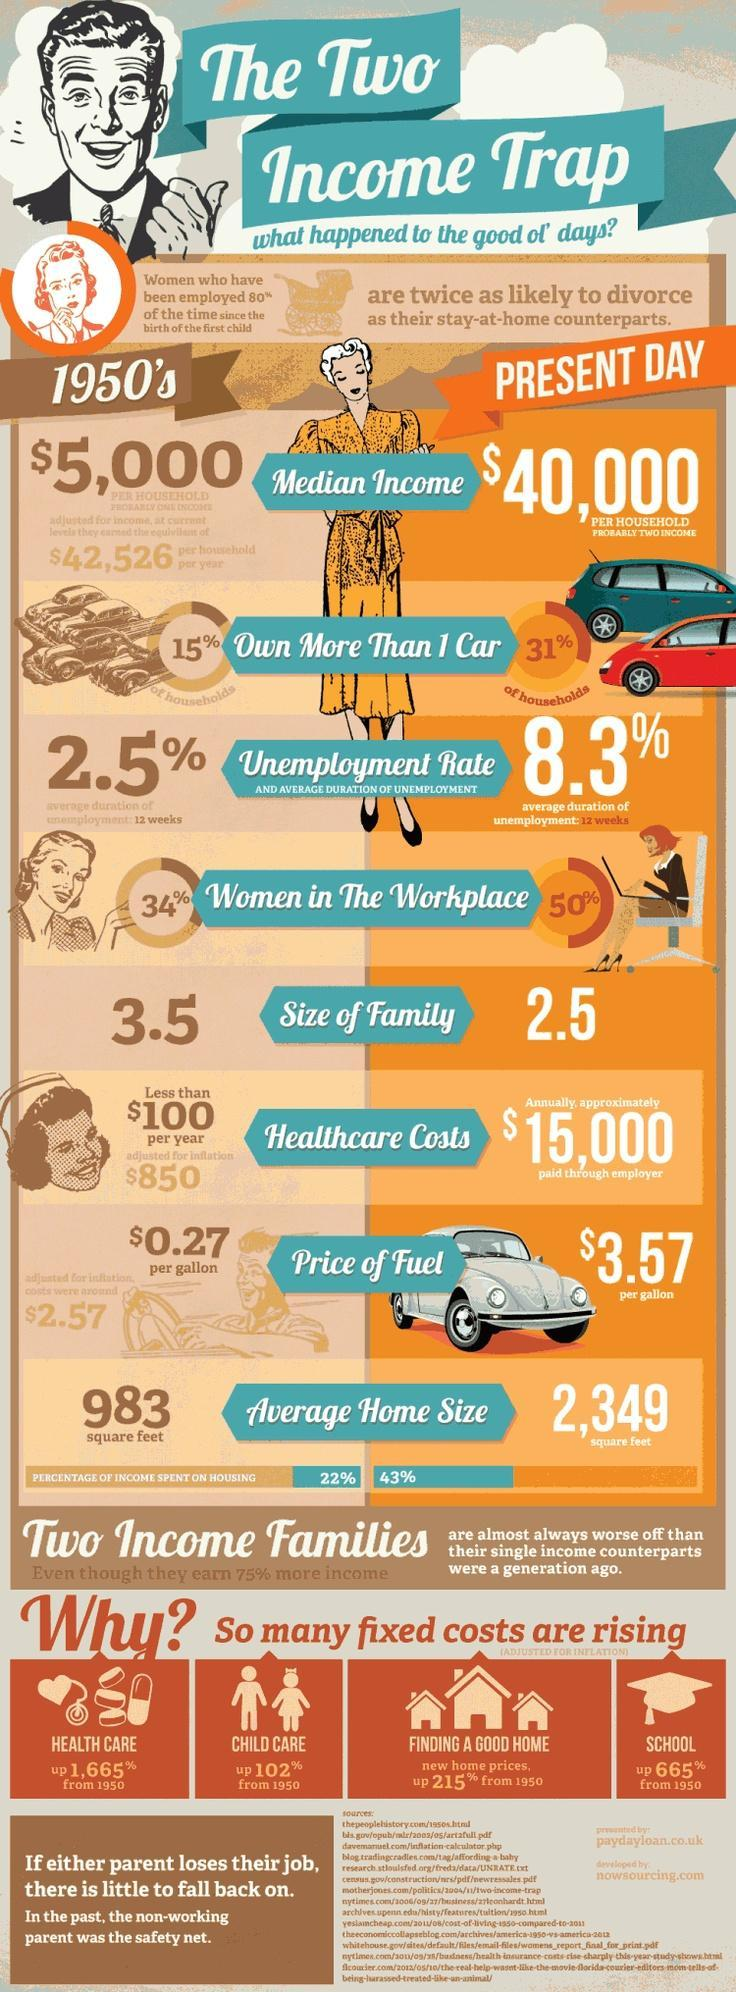Which cost has increased the most compared to 1950s?
Answer the question with a short phrase. Health care What is the third item mentioned in the comparison table between 1950s and present day? Unemployment Rate Who earns 75% more income? Two income families By what percentage have school costs gone up? 665% What has gone up by 102% from 1950? Child care 